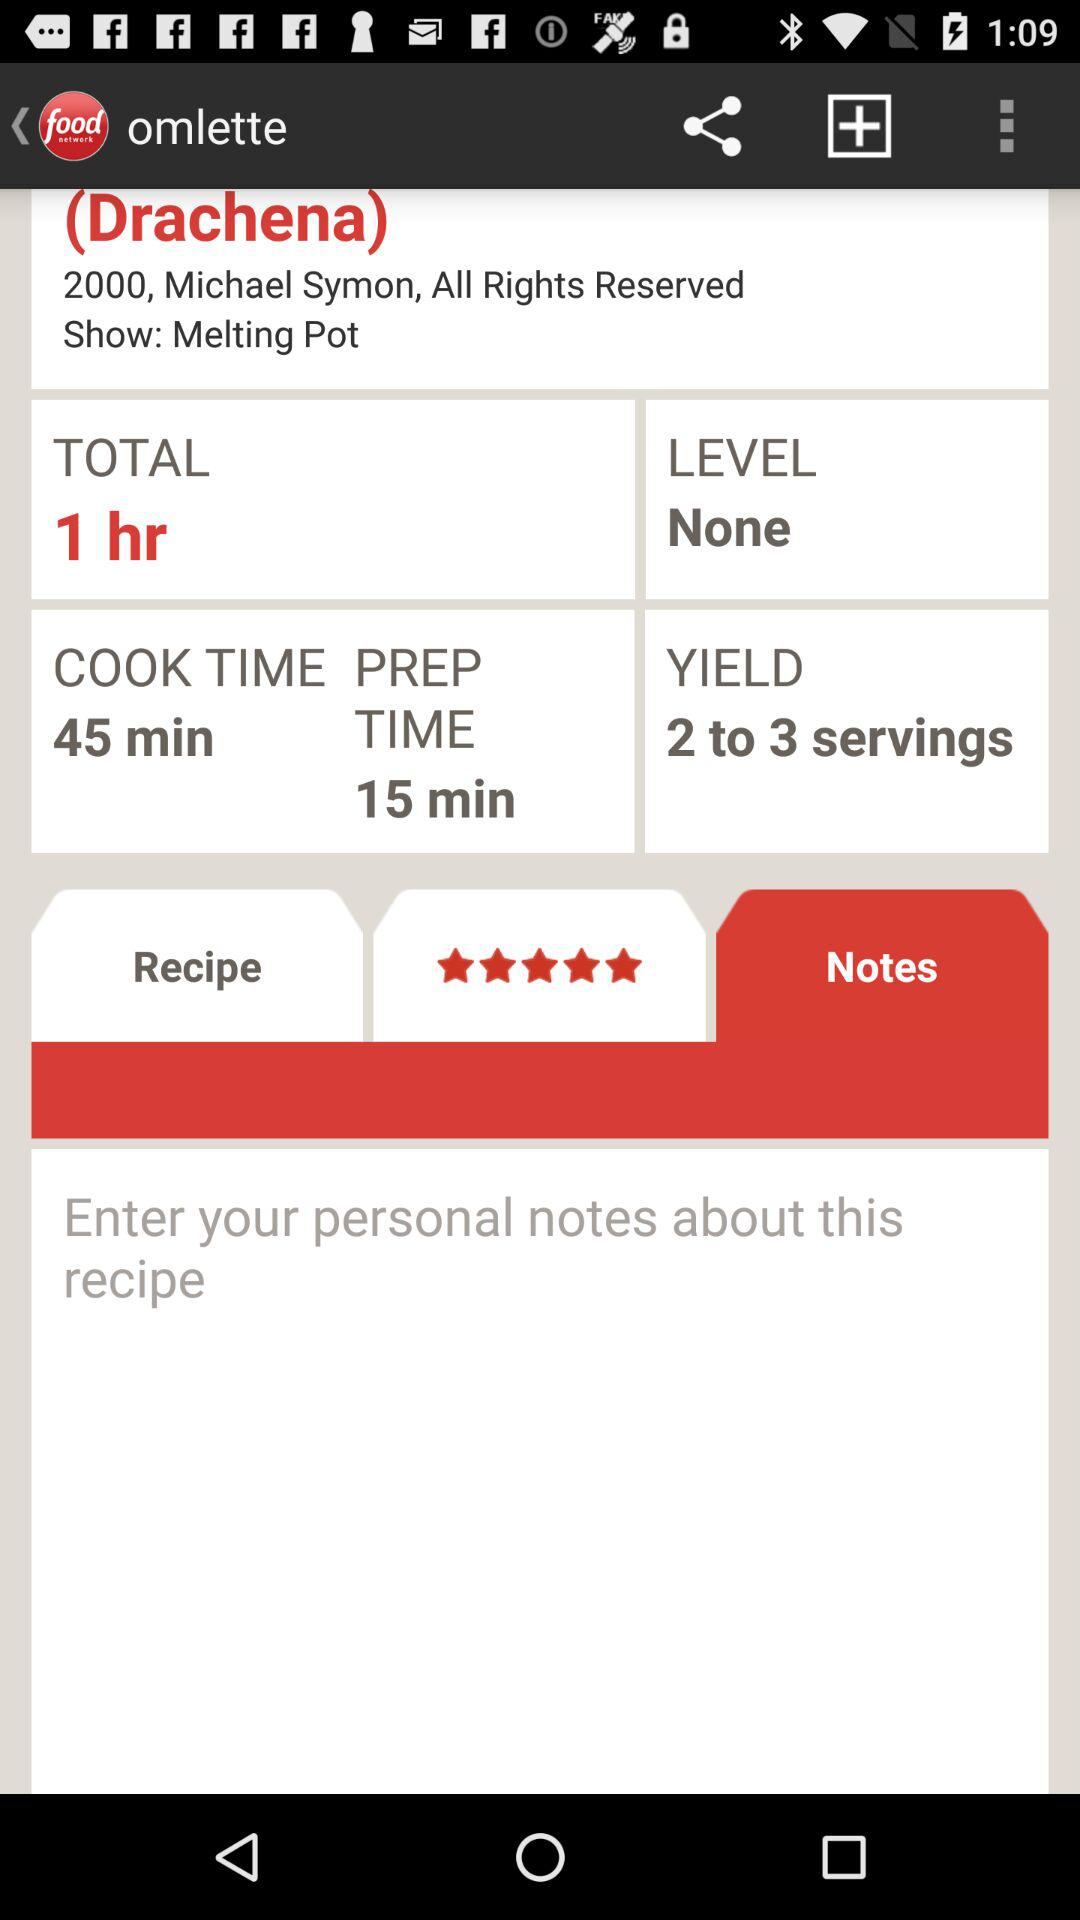What is the cooking time? The cooking time is 45 minutes. 